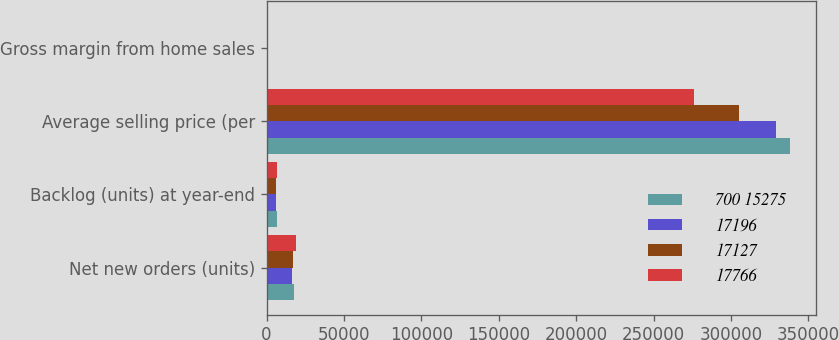Convert chart. <chart><loc_0><loc_0><loc_500><loc_500><stacked_bar_chart><ecel><fcel>Net new orders (units)<fcel>Backlog (units) at year-end<fcel>Average selling price (per<fcel>Gross margin from home sales<nl><fcel>700 15275<fcel>18008<fcel>6731<fcel>338000<fcel>23.3<nl><fcel>17196<fcel>16652<fcel>5850<fcel>329000<fcel>23.3<nl><fcel>17127<fcel>17080<fcel>5772<fcel>305000<fcel>20.5<nl><fcel>17766<fcel>19039<fcel>6458<fcel>276000<fcel>15.8<nl></chart> 